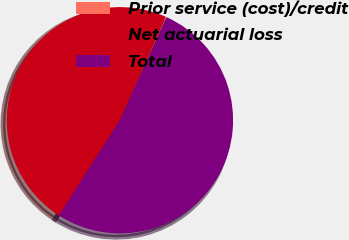Convert chart to OTSL. <chart><loc_0><loc_0><loc_500><loc_500><pie_chart><fcel>Prior service (cost)/credit<fcel>Net actuarial loss<fcel>Total<nl><fcel>0.13%<fcel>47.55%<fcel>52.31%<nl></chart> 